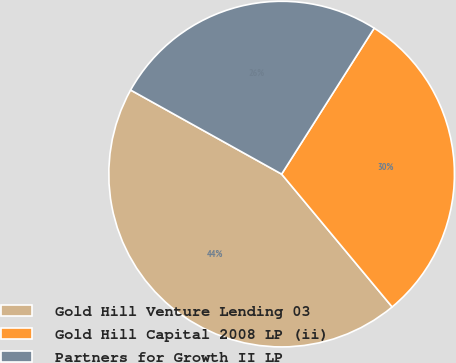<chart> <loc_0><loc_0><loc_500><loc_500><pie_chart><fcel>Gold Hill Venture Lending 03<fcel>Gold Hill Capital 2008 LP (ii)<fcel>Partners for Growth II LP<nl><fcel>44.13%<fcel>29.96%<fcel>25.91%<nl></chart> 